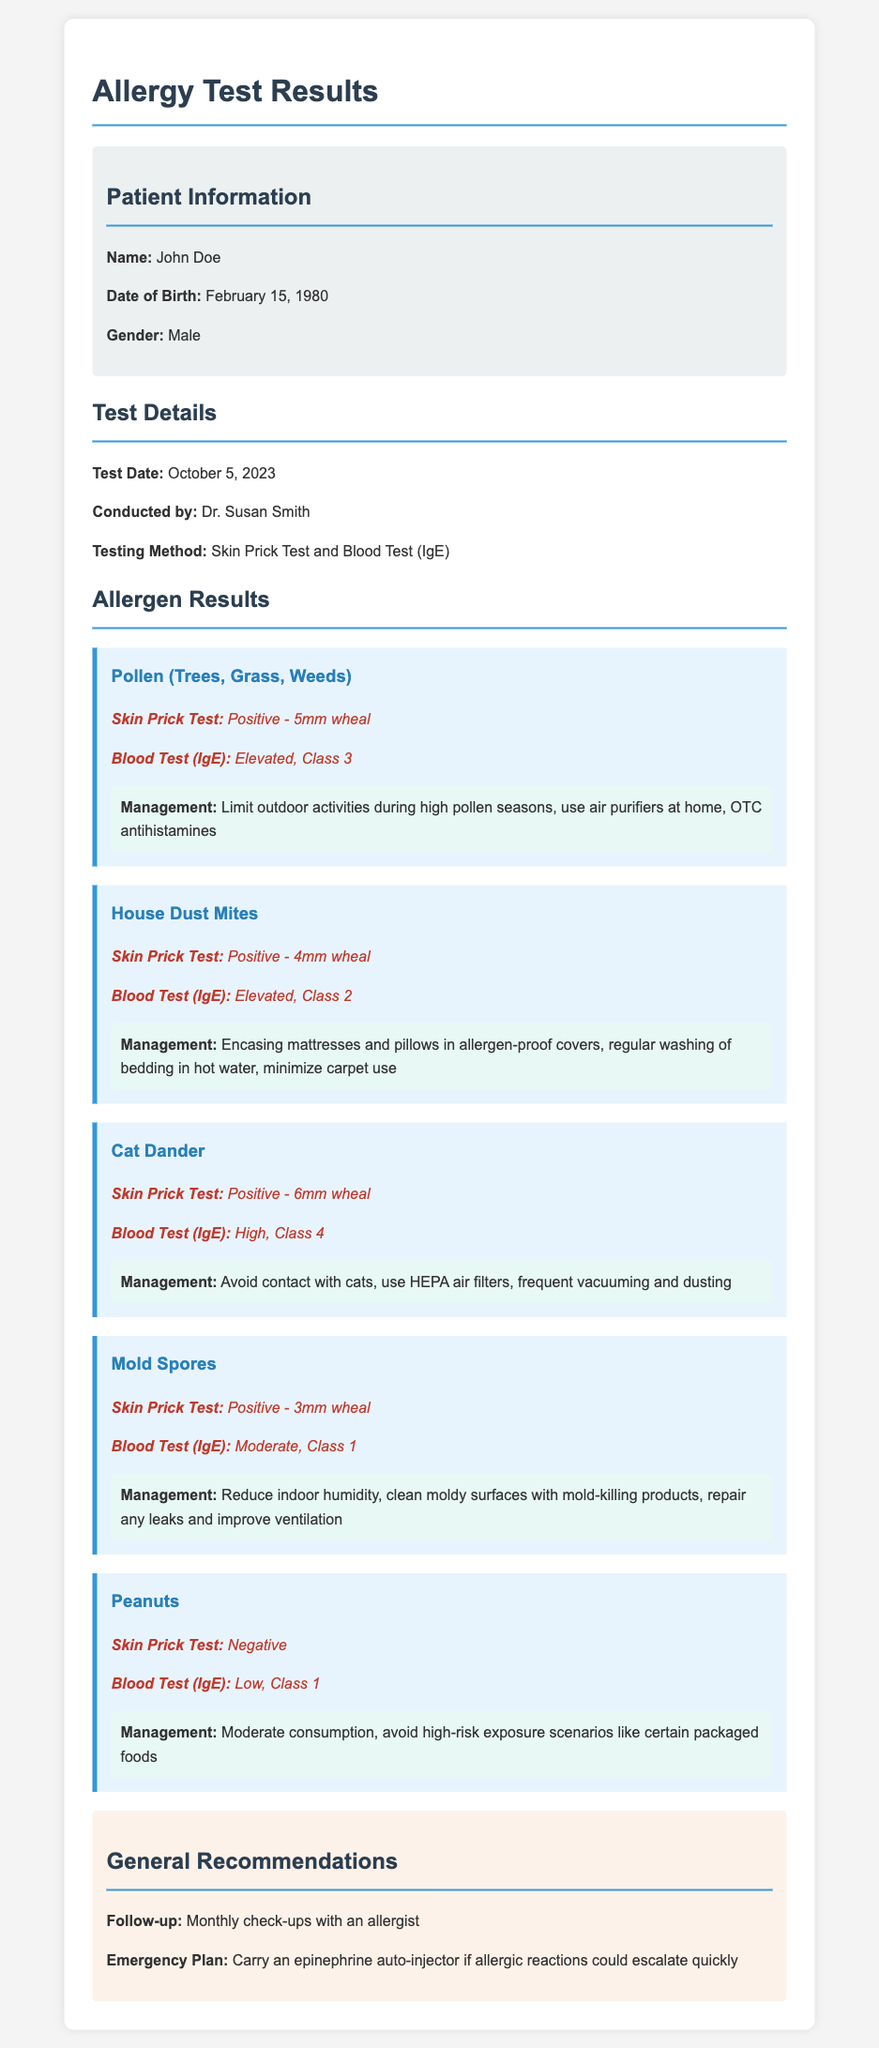What is the name of the patient? The patient's name is provided in the patient information section of the document, which states "John Doe."
Answer: John Doe Who conducted the allergy tests? The document mentions the name of the doctor who conducted the tests in the "Conducted by" section, which indicates "Dr. Susan Smith."
Answer: Dr. Susan Smith What was the skin prick test result for Cat Dander? The result for Cat Dander is found in the allergen section, which states "Positive - 6mm wheal."
Answer: Positive - 6mm wheal When were the tests conducted? The date the tests were performed is specified in the "Test Date" section of the document, which is "October 5, 2023."
Answer: October 5, 2023 What management strategy is suggested for House Dust Mites? Management recommendations for House Dust Mites are listed in its specific allergen section, indicating strategies to minimize exposure.
Answer: Encasing mattresses and pillows in allergen-proof covers, regular washing of bedding in hot water, minimize carpet use What is the blood test result classification for Pollen? The classification for Pollen is mentioned in the allergen results part of the document, indicating "Elevated, Class 3."
Answer: Elevated, Class 3 What is the emergency plan recommendation in the document? The emergency plan recommendation can be found in the "General Recommendations" section, stating what to carry in case of allergic reactions.
Answer: Carry an epinephrine auto-injector How many allergens were tested? The number of allergens tested can be inferred from the allergen results section, which lists the different allergens analyzed.
Answer: Five allergens 